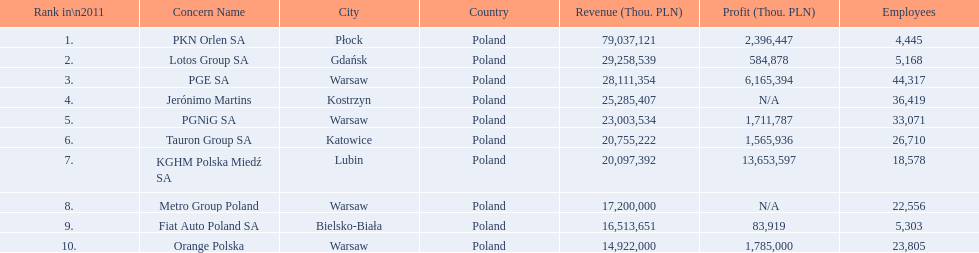What are the names of all the concerns? PKN Orlen SA, Lotos Group SA, PGE SA, Jerónimo Martins, PGNiG SA, Tauron Group SA, KGHM Polska Miedź SA, Metro Group Poland, Fiat Auto Poland SA, Orange Polska. How many employees does pgnig sa have? 33,071. 